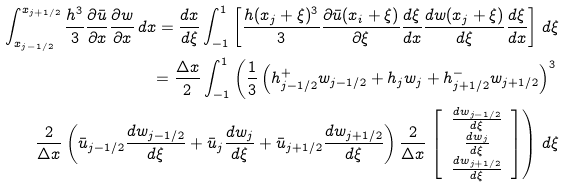Convert formula to latex. <formula><loc_0><loc_0><loc_500><loc_500>\int _ { x _ { j - 1 / 2 } } ^ { x _ { j + 1 / 2 } } \frac { h ^ { 3 } } { 3 } \frac { \partial \bar { u } } { \partial x } \frac { \partial w } { \partial x } \, d x = \frac { d x } { d \xi } \int _ { - 1 } ^ { 1 } \left [ \frac { h ( x _ { j } + \xi ) ^ { 3 } } { 3 } \frac { \partial \bar { u } ( x _ { i } + \xi ) } { \partial \xi } \frac { d \xi } { d x } \frac { d w ( x _ { j } + \xi ) } { d \xi } \frac { d \xi } { d x } \right ] \, d \xi \\ = \frac { \Delta x } { 2 } \int _ { - 1 } ^ { 1 } \left ( \frac { 1 } { 3 } \left ( h ^ { + } _ { j - 1 / 2 } w _ { j - 1 / 2 } + h _ { j } w _ { j } + h ^ { - } _ { j + 1 / 2 } w _ { j + 1 / 2 } \right ) ^ { 3 } \right . \\ \frac { 2 } { \Delta x } \left ( \bar { u } _ { j - 1 / 2 } \frac { d w _ { j - 1 / 2 } } { d \xi } + \bar { u } _ { j } \frac { d w _ { j } } { d \xi } + \bar { u } _ { j + 1 / 2 } \frac { d w _ { j + 1 / 2 } } { d \xi } \right ) \frac { 2 } { \Delta x } \left . \left [ \begin{array} { c } \frac { d w _ { j - 1 / 2 } } { d \xi } \\ \frac { d w _ { j } } { d \xi } \\ \frac { d w _ { j + 1 / 2 } } { d \xi } \\ \end{array} \right ] \right ) \, d \xi \\</formula> 